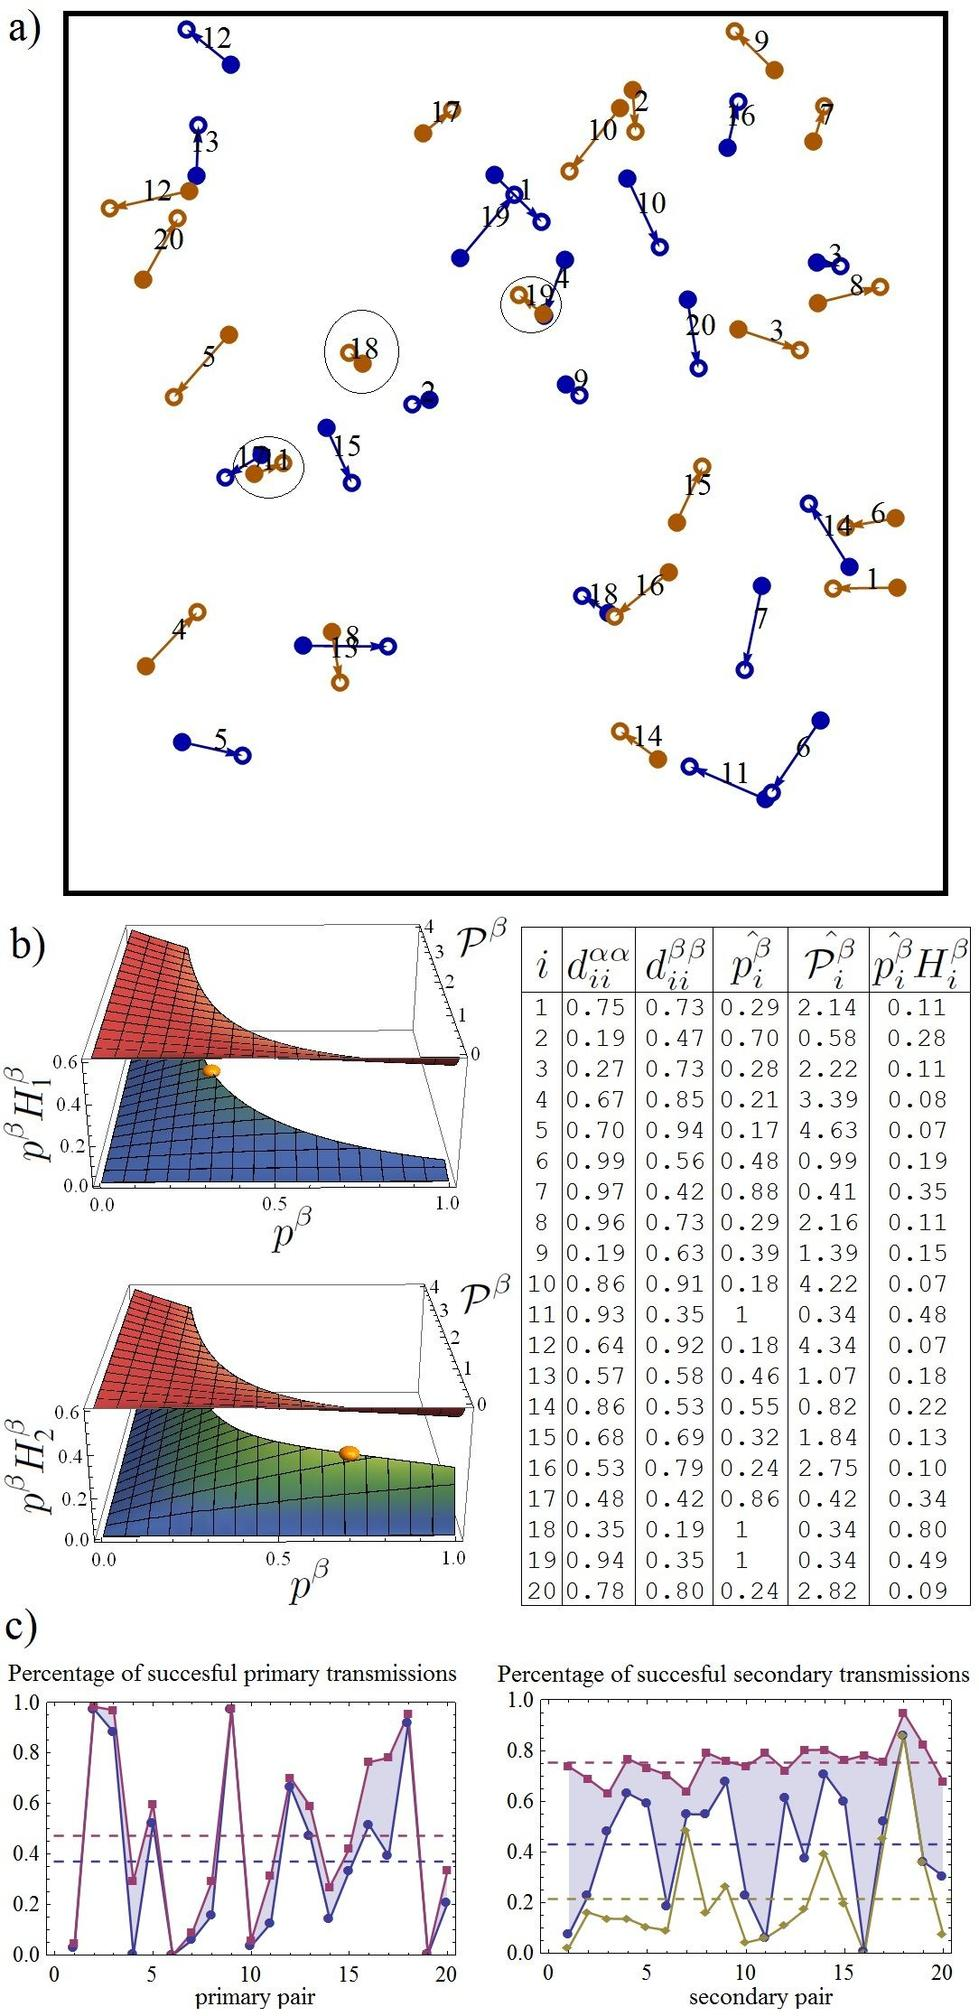What does the highlighted loop involving nodes Q15 and Q18 in figure a) suggest about their interaction? A) They have no interaction between them. B) They have a direct interaction with each other. C) They are part of a larger network but do not directly interact. D) They are completely isolated from the network. The highlighted loop between nodes Q15 and Q18 indicates a direct interaction between the two nodes, as evidenced by the connecting line which typically represents a relationship or interaction in network diagrams. Therefore, the correct answer is B. 